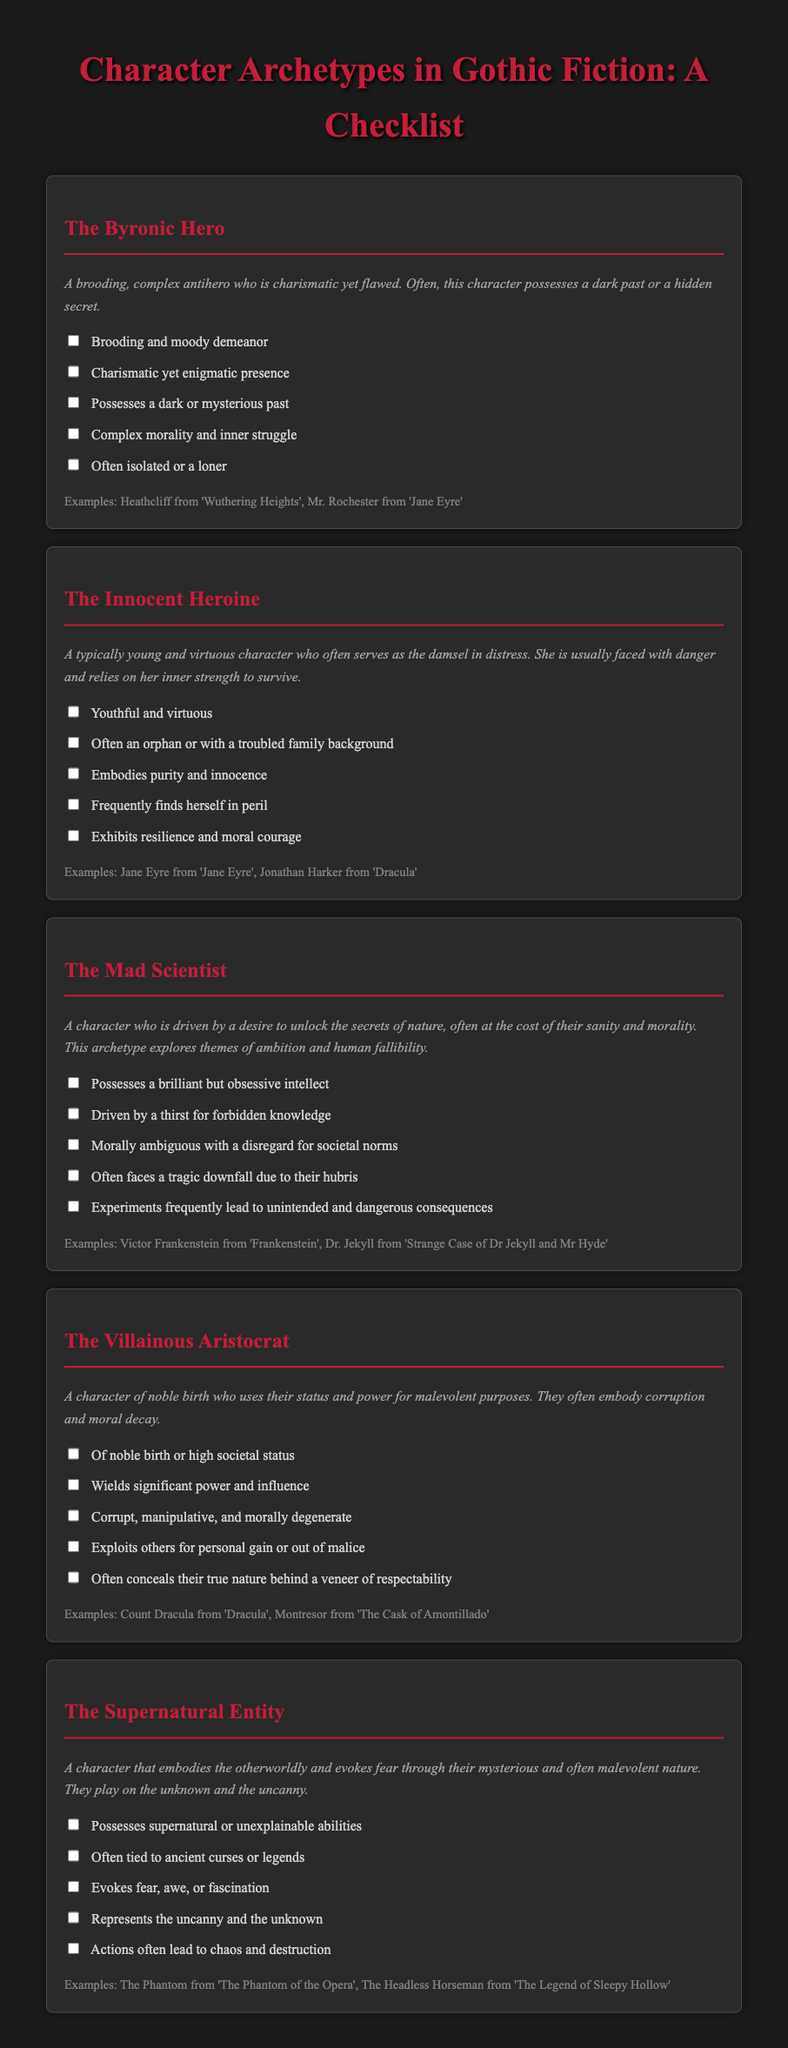What is the title of the document? The title is prominently displayed at the top of the checklist, indicating its main topic.
Answer: Character Archetypes in Gothic Fiction: A Checklist Who is an example of a Byronic Hero? The document provides examples for each archetype, including specific characters from literature.
Answer: Heathcliff What character archetype embodies purity and innocence? The checklist categorizes characters based on common traits, identifying their roles within gothic fiction.
Answer: The Innocent Heroine What are the main traits of The Mad Scientist? The checklist lists key characteristics that define this character archetype, emphasizing their obsessive nature.
Answer: Brilliant but obsessive intellect How many traits are listed for The Villainous Aristocrat? The number of traits outlined gives a clear structure for each character type, making it easy to understand.
Answer: Five What does The Supernatural Entity evoke? This captures the emotional and thematic response that the character aims to elicit within the narrative.
Answer: Fear, awe, or fascination Which character from 'Dracula' exemplifies the Villainous Aristocrat? The document provides specific instances of characters associated with each archetype, making it easy for readers to reference.
Answer: Count Dracula What common theme is explored through The Mad Scientist archetype? The checklist summarizes the broader narrative concerns linked to this character type, emphasizing the moral implications.
Answer: Ambition and human fallibility What is the typical role of The Innocent Heroine in a story? The archetype's role is defined by its frequent circumstances and character behaviors outlined in the document.
Answer: Damsel in distress 